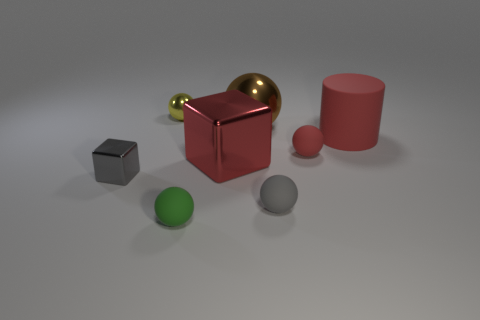Subtract all brown balls. How many balls are left? 4 Subtract all yellow balls. How many balls are left? 4 Subtract all green spheres. Subtract all yellow blocks. How many spheres are left? 4 Add 2 large gray cylinders. How many objects exist? 10 Subtract all cylinders. How many objects are left? 7 Add 5 tiny purple shiny cylinders. How many tiny purple shiny cylinders exist? 5 Subtract 0 cyan spheres. How many objects are left? 8 Subtract all red rubber cylinders. Subtract all red metallic things. How many objects are left? 6 Add 3 small cubes. How many small cubes are left? 4 